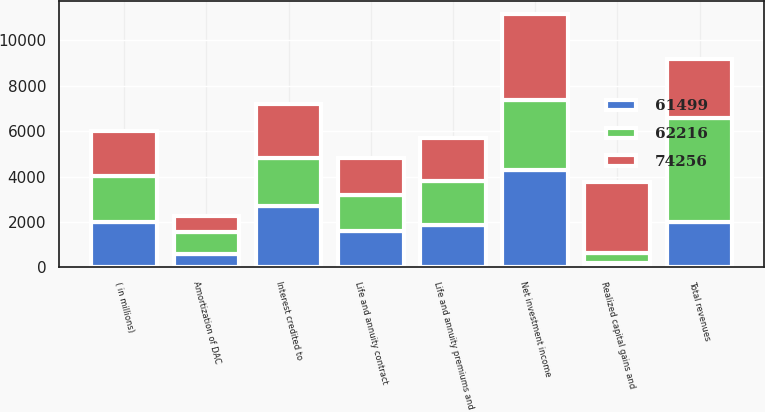Convert chart. <chart><loc_0><loc_0><loc_500><loc_500><stacked_bar_chart><ecel><fcel>( in millions)<fcel>Life and annuity premiums and<fcel>Net investment income<fcel>Realized capital gains and<fcel>Total revenues<fcel>Life and annuity contract<fcel>Interest credited to<fcel>Amortization of DAC<nl><fcel>62216<fcel>2009<fcel>1958<fcel>3064<fcel>431<fcel>4591<fcel>1617<fcel>2126<fcel>965<nl><fcel>74256<fcel>2008<fcel>1895<fcel>3811<fcel>3127<fcel>2579<fcel>1612<fcel>2411<fcel>704<nl><fcel>61499<fcel>2007<fcel>1866<fcel>4297<fcel>193<fcel>2007<fcel>1589<fcel>2681<fcel>583<nl></chart> 